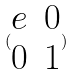Convert formula to latex. <formula><loc_0><loc_0><loc_500><loc_500>( \begin{matrix} e & 0 \\ 0 & 1 \end{matrix} )</formula> 